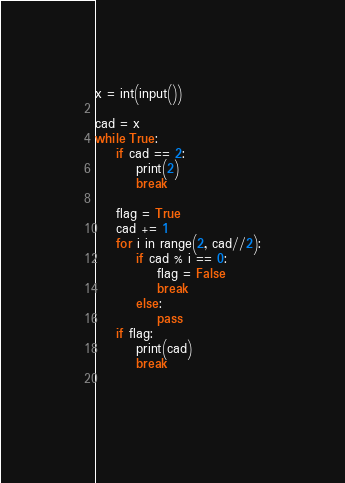Convert code to text. <code><loc_0><loc_0><loc_500><loc_500><_Python_>x = int(input())

cad = x
while True:
    if cad == 2:
        print(2)
        break
    
    flag = True
    cad += 1
    for i in range(2, cad//2):
        if cad % i == 0:
            flag = False
            break
        else:
            pass
    if flag:
        print(cad)
        break
        
    </code> 